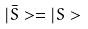Convert formula to latex. <formula><loc_0><loc_0><loc_500><loc_500>| \bar { S } > = | S ></formula> 